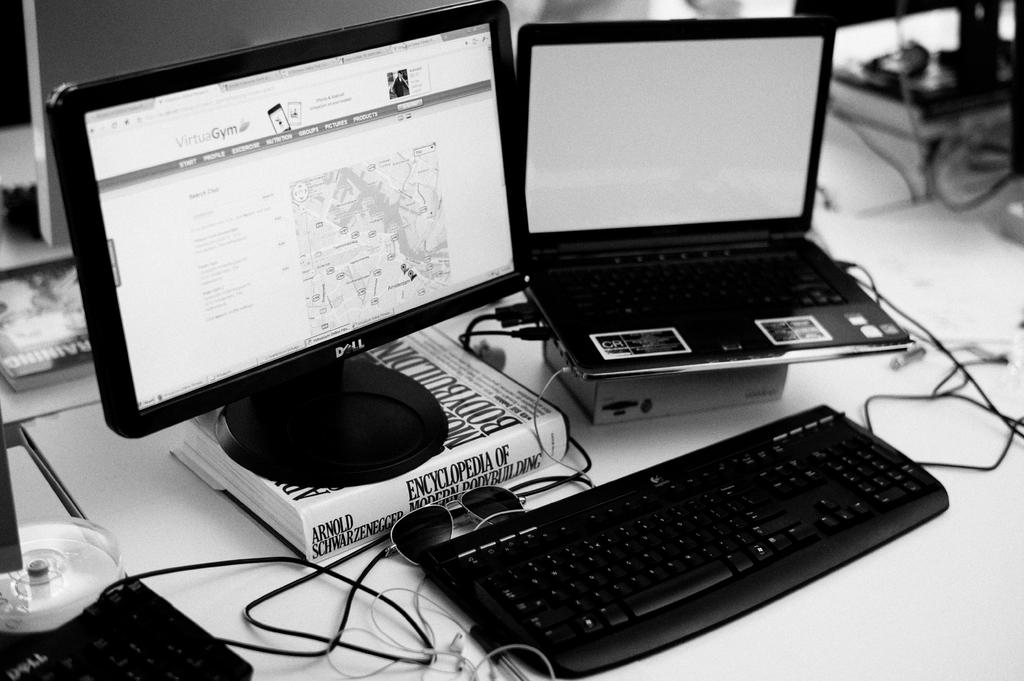What type of furniture is visible in the image? There is a desktop in the image. What is placed on the desktop? There is a keyboard on a table in the image. What type of science experiment is being conducted on the desktop in the image? There is no science experiment visible in the image; it only shows a desktop with a keyboard on it. 